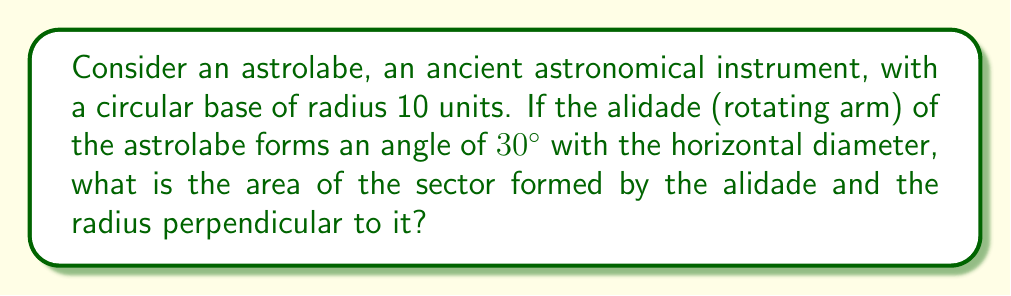Give your solution to this math problem. Let's approach this step-by-step:

1) The astrolabe's base is a circle with radius $r = 10$ units.

2) The angle formed by the alidade is $30°$ or $\frac{\pi}{6}$ radians.

3) The area of a sector is given by the formula:

   $$A = \frac{1}{2}r^2\theta$$

   Where $A$ is the area, $r$ is the radius, and $\theta$ is the angle in radians.

4) Substituting our values:

   $$A = \frac{1}{2} \cdot 10^2 \cdot \frac{\pi}{6}$$

5) Simplify:

   $$A = 50 \cdot \frac{\pi}{6} = \frac{25\pi}{3}$$

6) This can be approximated to about 26.18 square units.

[asy]
import geometry;

size(200);
draw(circle((0,0),10));
draw((0,0)--(8.66,5),arrow=Arrow(TeXHead));
draw((0,0)--(10,0));
draw((0,0)--(0,10));
label("30°", (3,1.5));
label("r=10", (5,-1));
fill(arc((0,0),10,0,30)--cycle,lightgray);
</asy]

This diagram illustrates the astrolabe's base, the alidade, and the sector in question.
Answer: $\frac{25\pi}{3}$ square units 